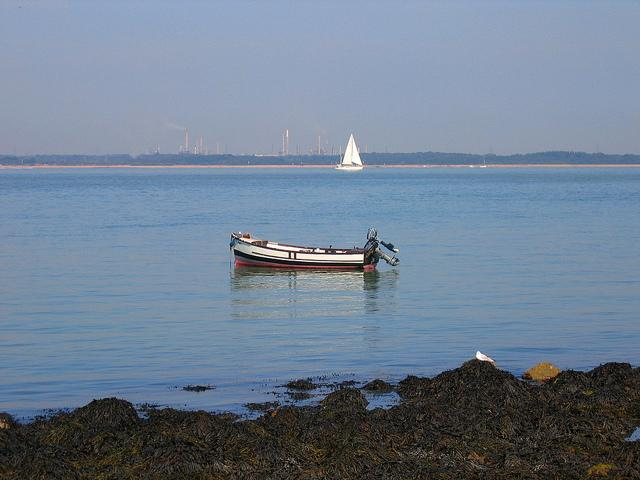What is in the background?

Choices:
A) palm tree
B) sailboat
C) fisherman
D) baby sailboat 